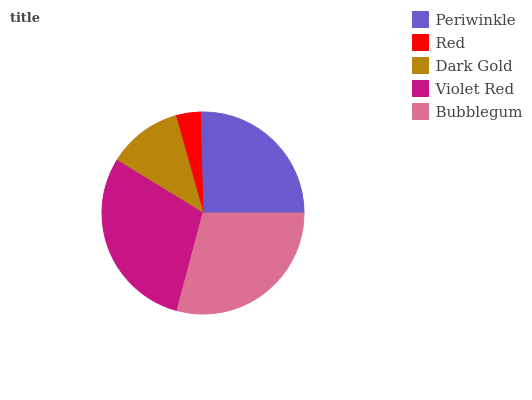Is Red the minimum?
Answer yes or no. Yes. Is Violet Red the maximum?
Answer yes or no. Yes. Is Dark Gold the minimum?
Answer yes or no. No. Is Dark Gold the maximum?
Answer yes or no. No. Is Dark Gold greater than Red?
Answer yes or no. Yes. Is Red less than Dark Gold?
Answer yes or no. Yes. Is Red greater than Dark Gold?
Answer yes or no. No. Is Dark Gold less than Red?
Answer yes or no. No. Is Periwinkle the high median?
Answer yes or no. Yes. Is Periwinkle the low median?
Answer yes or no. Yes. Is Violet Red the high median?
Answer yes or no. No. Is Dark Gold the low median?
Answer yes or no. No. 